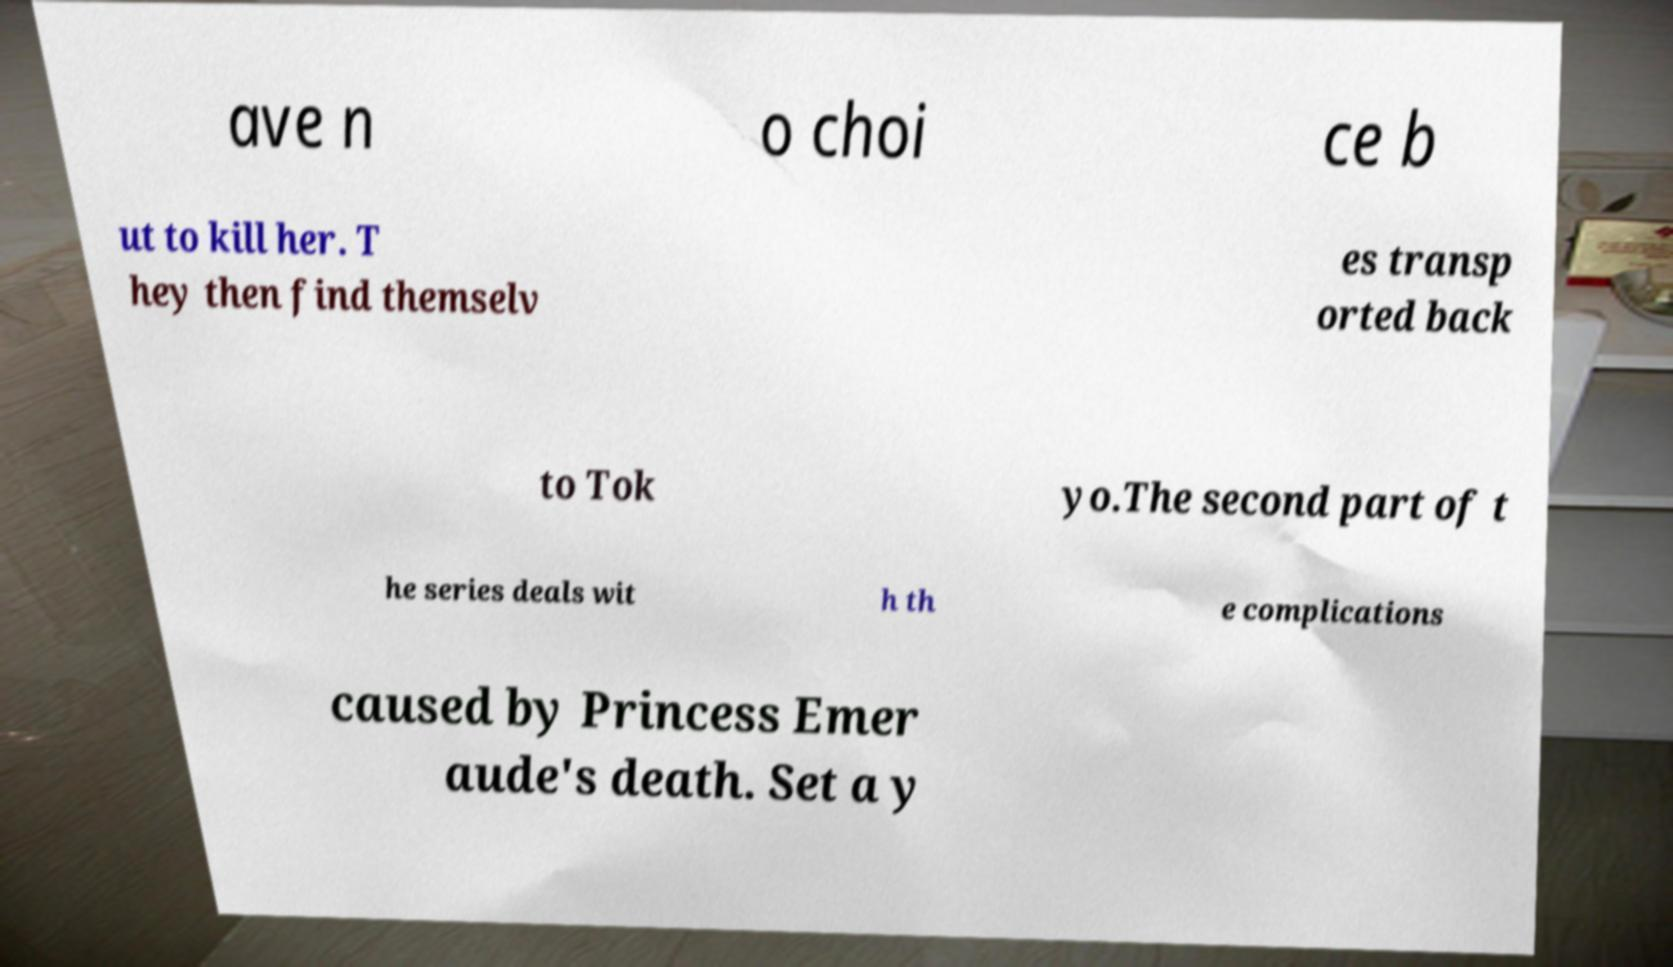For documentation purposes, I need the text within this image transcribed. Could you provide that? ave n o choi ce b ut to kill her. T hey then find themselv es transp orted back to Tok yo.The second part of t he series deals wit h th e complications caused by Princess Emer aude's death. Set a y 